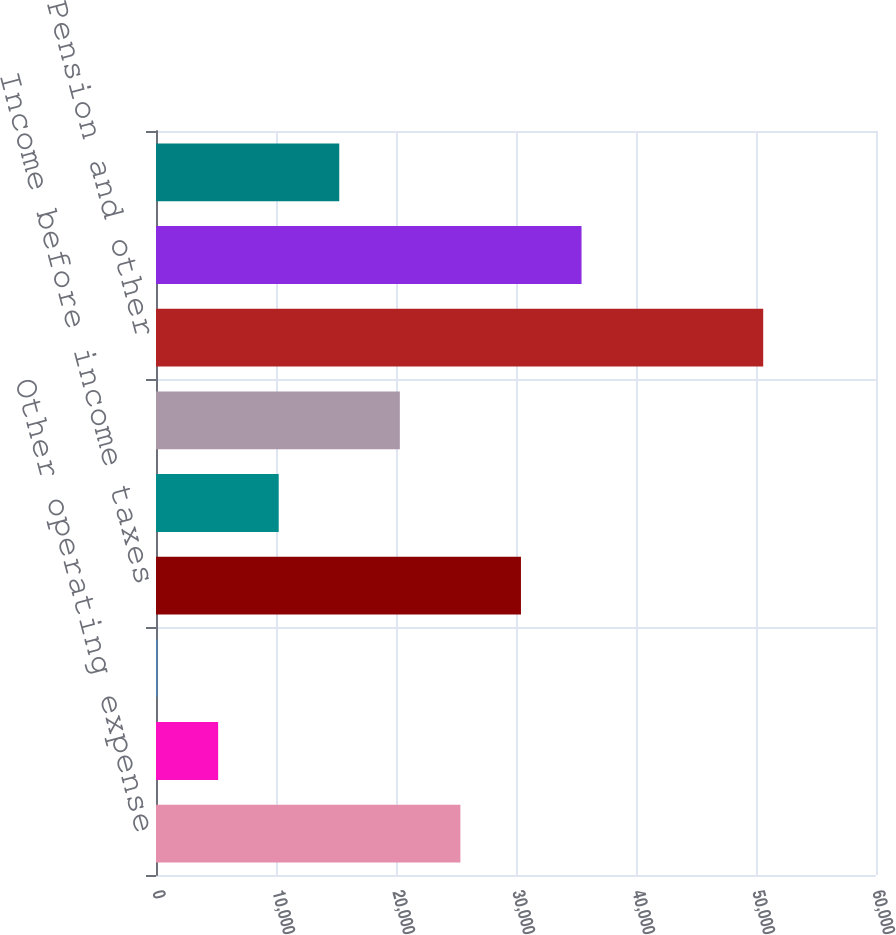<chart> <loc_0><loc_0><loc_500><loc_500><bar_chart><fcel>Other operating expense<fcel>Provision for depreciation<fcel>Capitalized interest<fcel>Income before income taxes<fcel>Income taxes<fcel>Net Income<fcel>Pension and other<fcel>Income taxes (benefits) on<fcel>Comprehensive income<nl><fcel>25366.5<fcel>5178.9<fcel>132<fcel>30413.4<fcel>10225.8<fcel>20319.6<fcel>50601<fcel>35460.3<fcel>15272.7<nl></chart> 